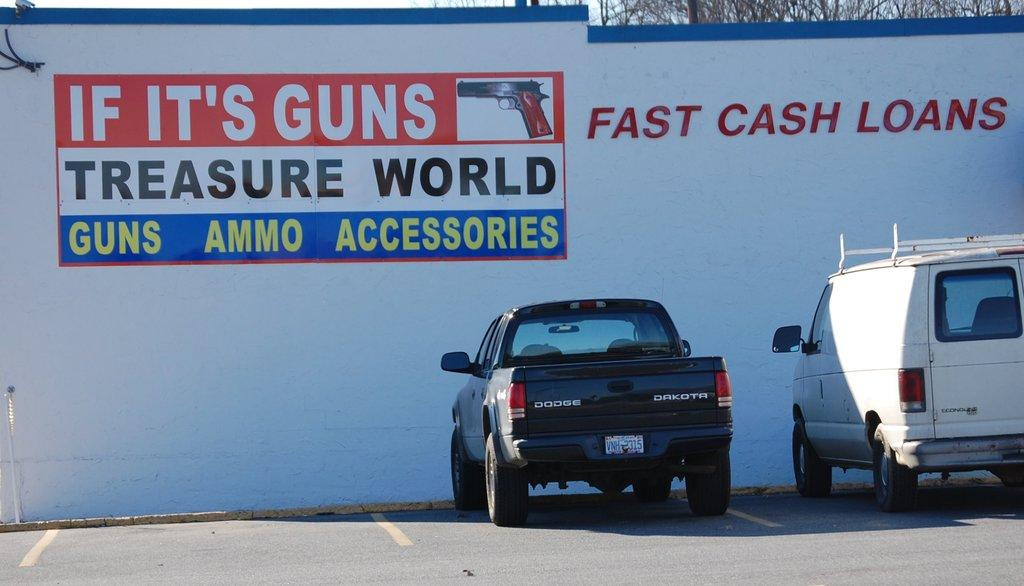Provide a one-sentence caption for the provided image. A building that is titled Fast Cash Loans. 